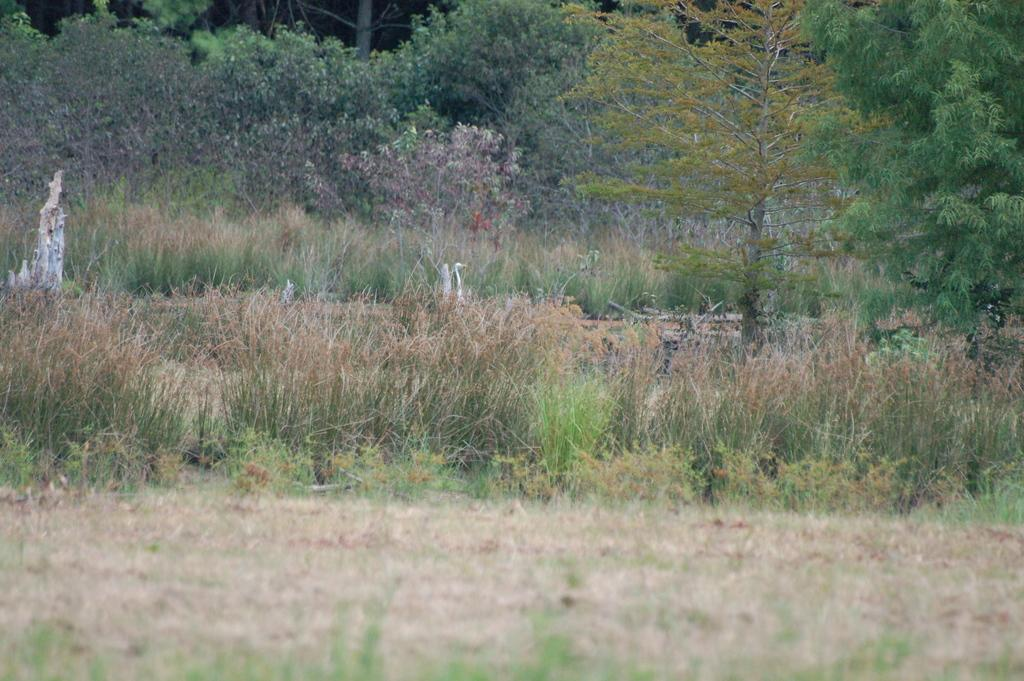What type of surface is visible in the image? There is a grassy surface in the image. What types of vegetation can be seen in the image? Plants, grass plants, trees, and bushes are visible in the image. What color is the parent's shirt in the image? There is no parent or shirt present in the image. How does the heat affect the plants in the image? The image does not provide information about the temperature or heat, so it cannot be determined how it affects the plants. 